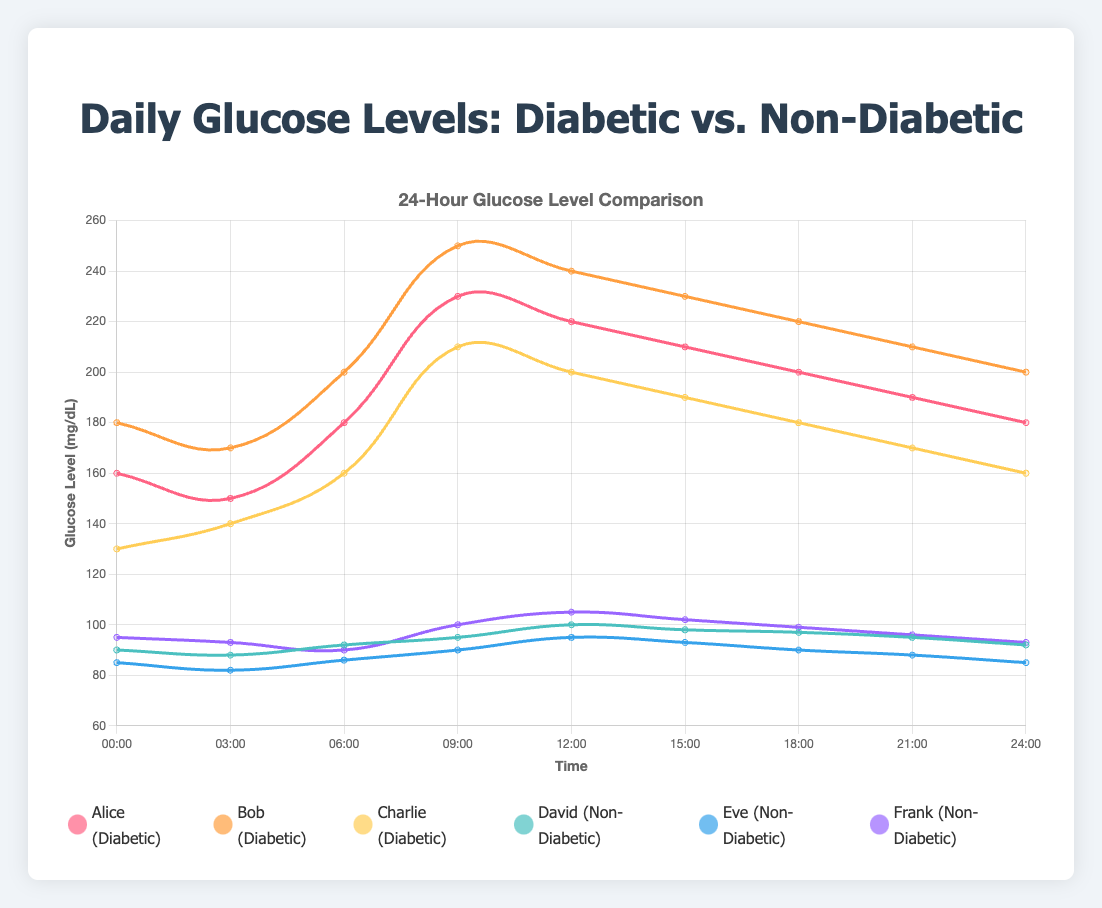What's the average glucose level of Bob (Diabetic) throughout the day? To find Bob's average glucose level, sum his glucose levels at each time point and divide by the number of measurements. (180 + 170 + 200 + 250 + 240 + 230 + 220 + 210 + 200) / 9 = 210
Answer: 210 Which individual has the lowest glucose level among non-diabetics at 12:00? At 12:00, the glucose levels for non-diabetics are David: 100, Eve: 95, Frank: 105. Eve has the lowest glucose level.
Answer: Eve What is the difference between the highest and lowest glucose levels for Alice (Diabetic) over the 24-hour period? The highest glucose level for Alice is 230 at 09:00, and the lowest is 150 at 03:00. The difference is 230 - 150 = 80
Answer: 80 Who has more stable glucose levels, Charlie (Diabetic) or Frank (Non-Diabetic)? To determine stability, observe the range of glucose levels. Charlie's levels range from 130 to 210 (range = 80), while Frank's range from 90 to 105 (range = 15). Frank's levels are more stable.
Answer: Frank At which time do all three non-diabetic individuals have nearly the same glucose levels? Look for the time when non-diabetic glucose levels are closest: At 09:00, the levels are David: 95, Eve: 90, Frank: 100 (range = 10, closest match).
Answer: 09:00 Which diabetic individual shows the greatest increase in glucose levels between 06:00 and 09:00? Compute the increase for each: Alice from 180 to 230 (50), Bob from 200 to 250 (50), Charlie from 160 to 210 (50). All three show the same increase (50).
Answer: Alice, Bob, Charlie Compare the glucose levels of Eve (Non-Diabetic) and Charlie (Diabetic) at 18:00. Who has higher levels? At 18:00, Eve's glucose level is 90, and Charlie's is 180. Charlie has higher levels.
Answer: Charlie What is the trend in Bob's (Diabetic) glucose levels from 09:00 to 18:00? At 09:00, Bob's level is 250; 12:00: 240; 15:00: 230; 18:00: 220. There is a decreasing trend.
Answer: Decreasing Identify the highest glucose level recorded for non-diabetics throughout the day. The non-diabetic levels: David: 100, Eve: 95, Frank: 105 (at 12:00). The highest is 105.
Answer: 105 